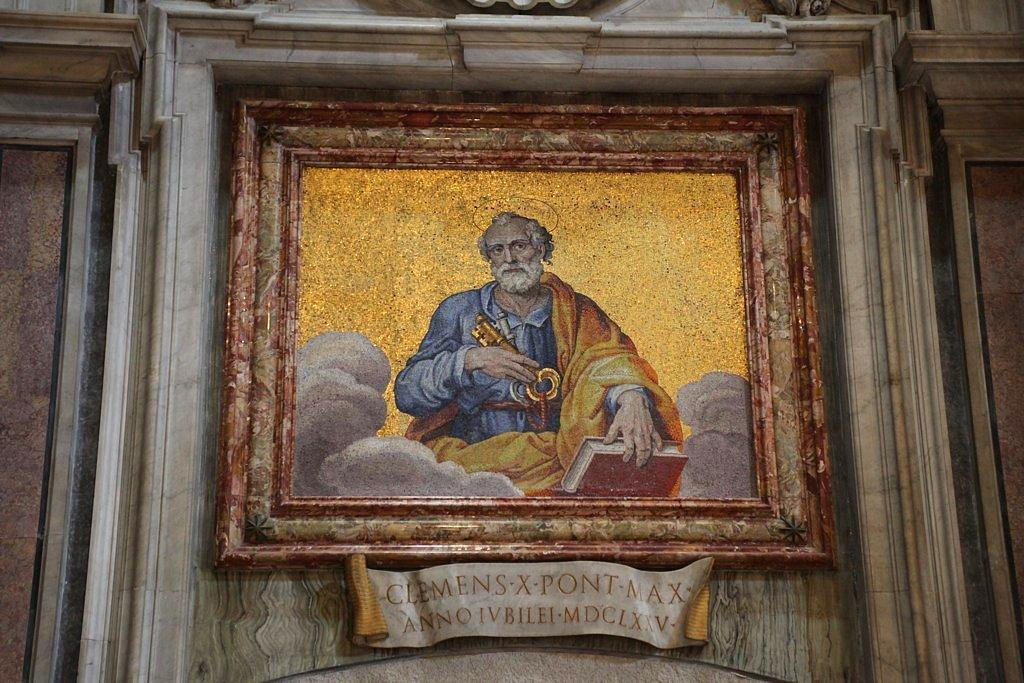<image>
Create a compact narrative representing the image presented. An old picture in a frame which reads Clemens Xpont Max 